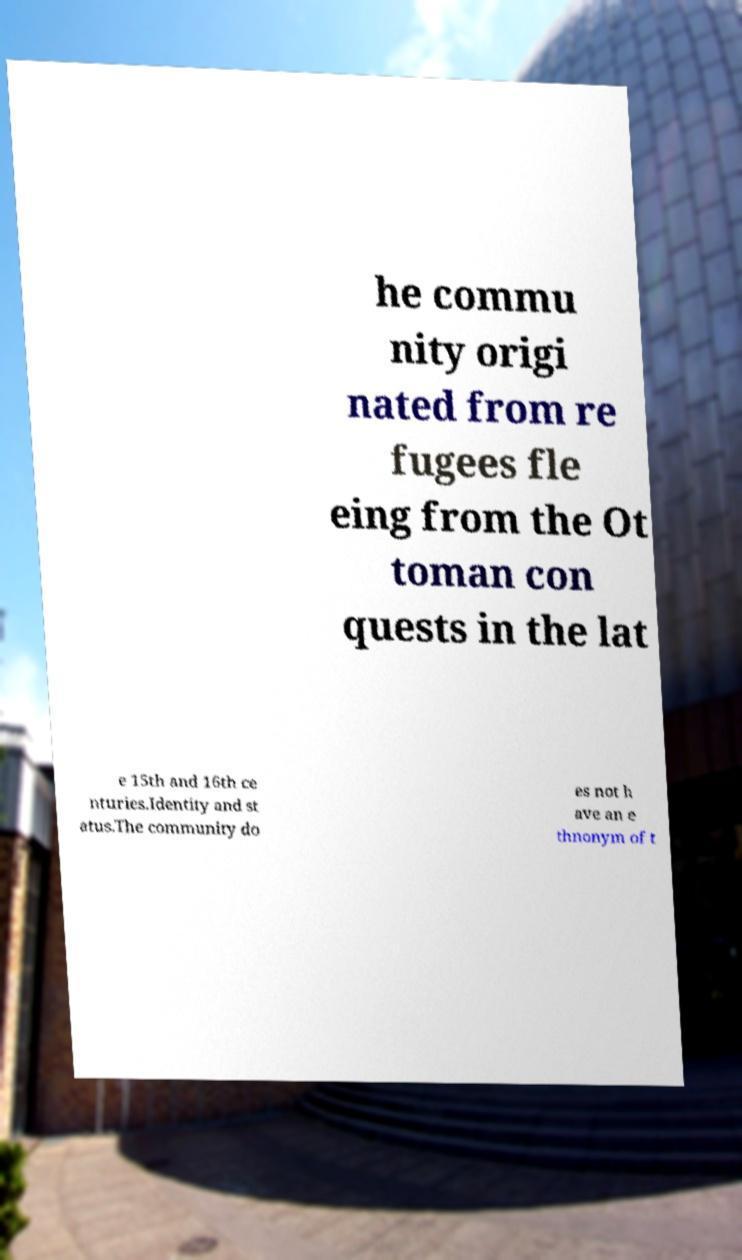Could you assist in decoding the text presented in this image and type it out clearly? he commu nity origi nated from re fugees fle eing from the Ot toman con quests in the lat e 15th and 16th ce nturies.Identity and st atus.The community do es not h ave an e thnonym of t 